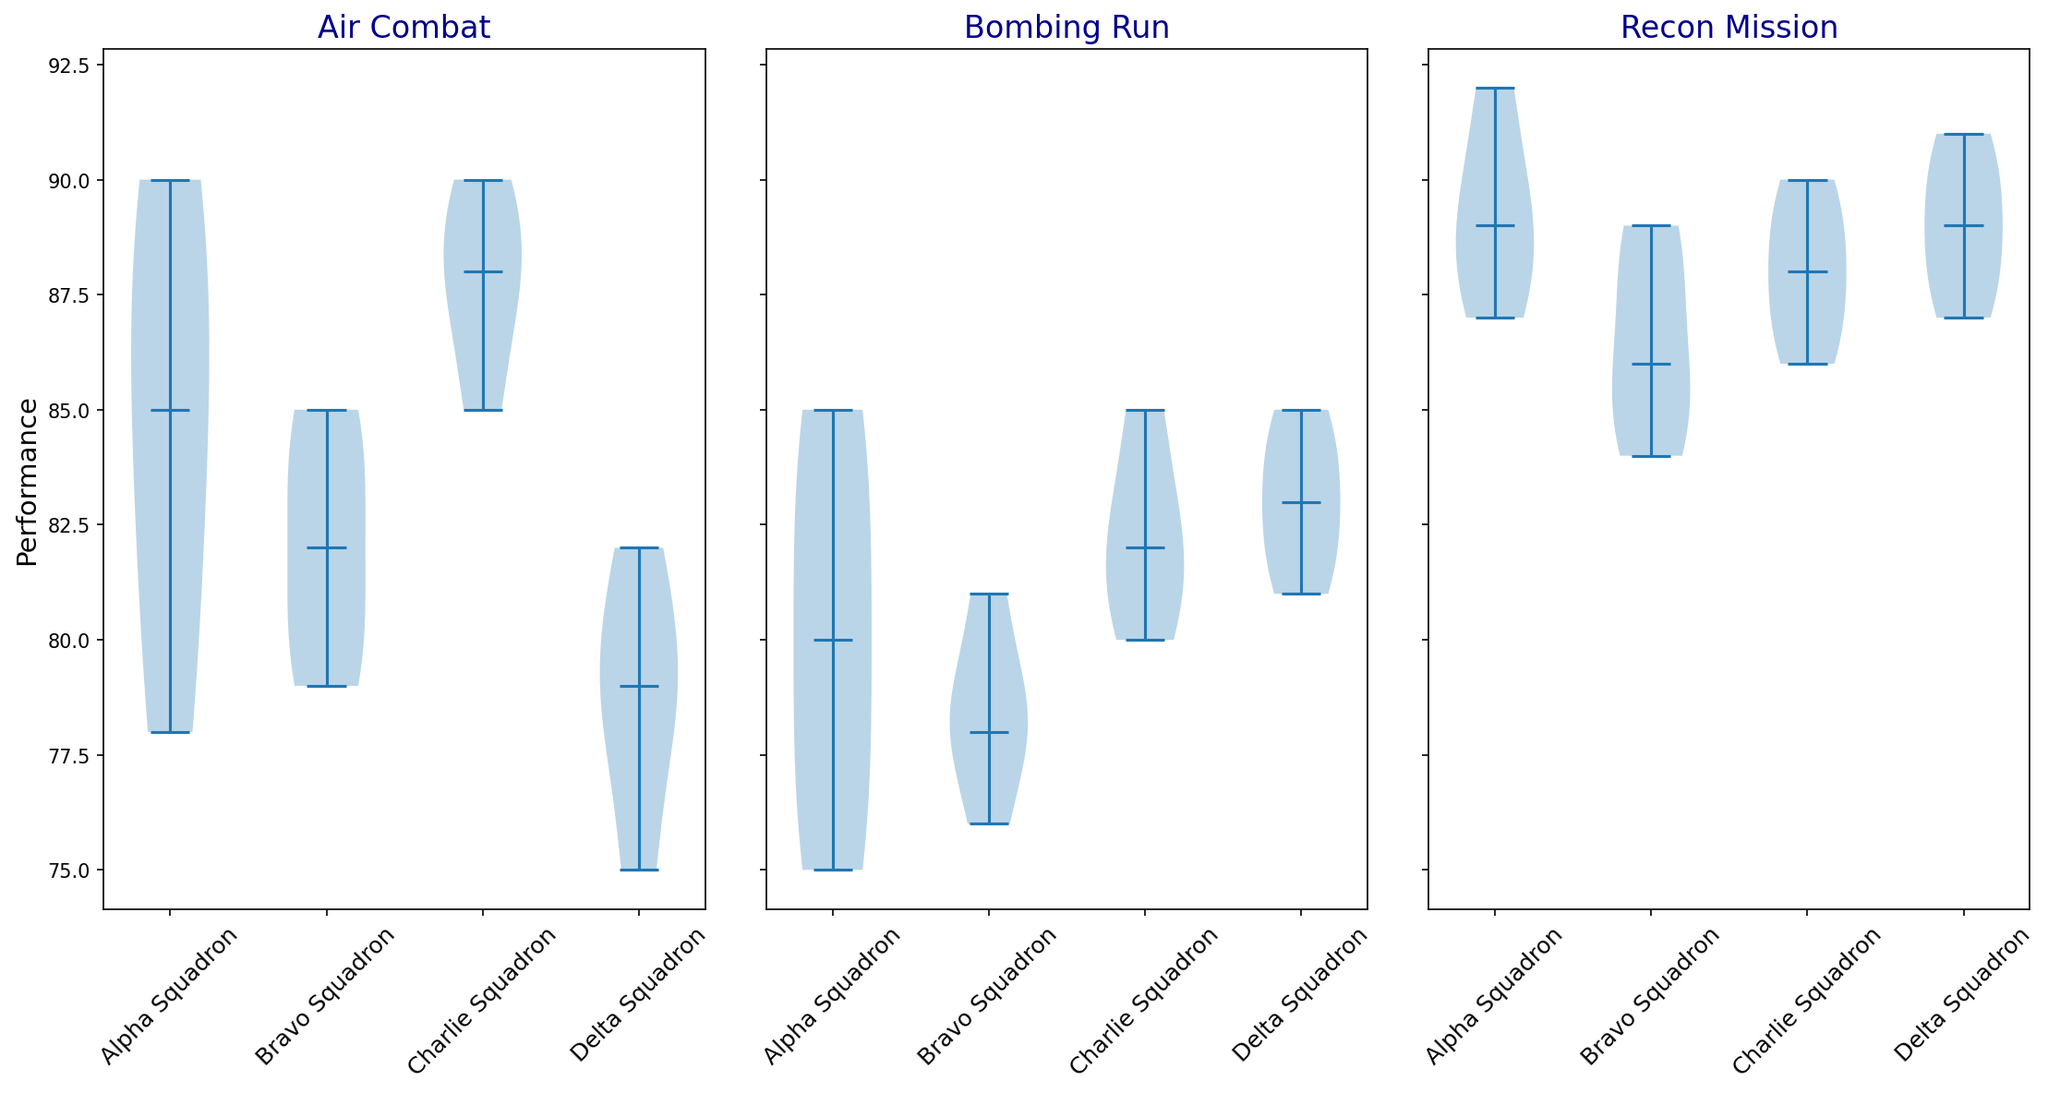How many exercises are displayed in the plot? The plot has separate sections for each exercise; count these sections.
Answer: 3 Which squadron has the widest performance distribution range in Air Combat? Look for the longest vertical spread in the Air Combat section of the plot.
Answer: Alpha Squadron Are there more exercises where Alpha Squadron's median performance is above 85? Check the median line of the violin plots for each exercise for Alpha Squadron and count those above 85.
Answer: Yes Which squadron has the most consistent performance in Bombing Run? Identify the most compressed (least spread) violin plot for Bombing Run.
Answer: Bravo Squadron Is the median performance of the Delta Squadron in Recon Mission above or below 90? Locate the median line in the violin plot for Delta Squadron in Recon Mission and observe its position relative to 90.
Answer: Below Which exercise has the highest overall median performance across all squadrons? Compare the median lines of the violin plots across different exercises to see which is the highest.
Answer: Recon Mission How does Bravo Squadron's performance in Recon Mission compare to Alpha Squadron's in the same exercise? Compare the height and spread of Bravo Squadron's violin plot to Alpha Squadron's for Recon Mission.
Answer: Lower Which squadrons show a median performance equal to 85 in any of the exercises? Look for violin plots where the median line matches 85 and note the corresponding squadrons.
Answer: Alpha Squadron and Bravo Squadron On average, do squadrons perform better in Air Combat or Bombing Run? Visually estimate the center and spread of the violin plots for Air Combat and Bombing Run and compare.
Answer: Air Combat What is the approximate performance range (from minimum to maximum) for Charlie Squadron in Air Combat? Observe the highest and lowest points of the Charlie Squadron violin plot in Air Combat to determine the range.
Answer: 85 to 90 